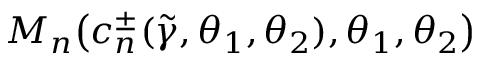Convert formula to latex. <formula><loc_0><loc_0><loc_500><loc_500>M _ { n } \left ( c _ { n } ^ { \pm } ( \widetilde { \gamma } , \theta _ { 1 } , \theta _ { 2 } ) , \theta _ { 1 } , \theta _ { 2 } \right )</formula> 